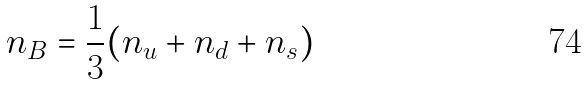Convert formula to latex. <formula><loc_0><loc_0><loc_500><loc_500>n _ { B } = \frac { 1 } { 3 } ( n _ { u } + n _ { d } + n _ { s } )</formula> 